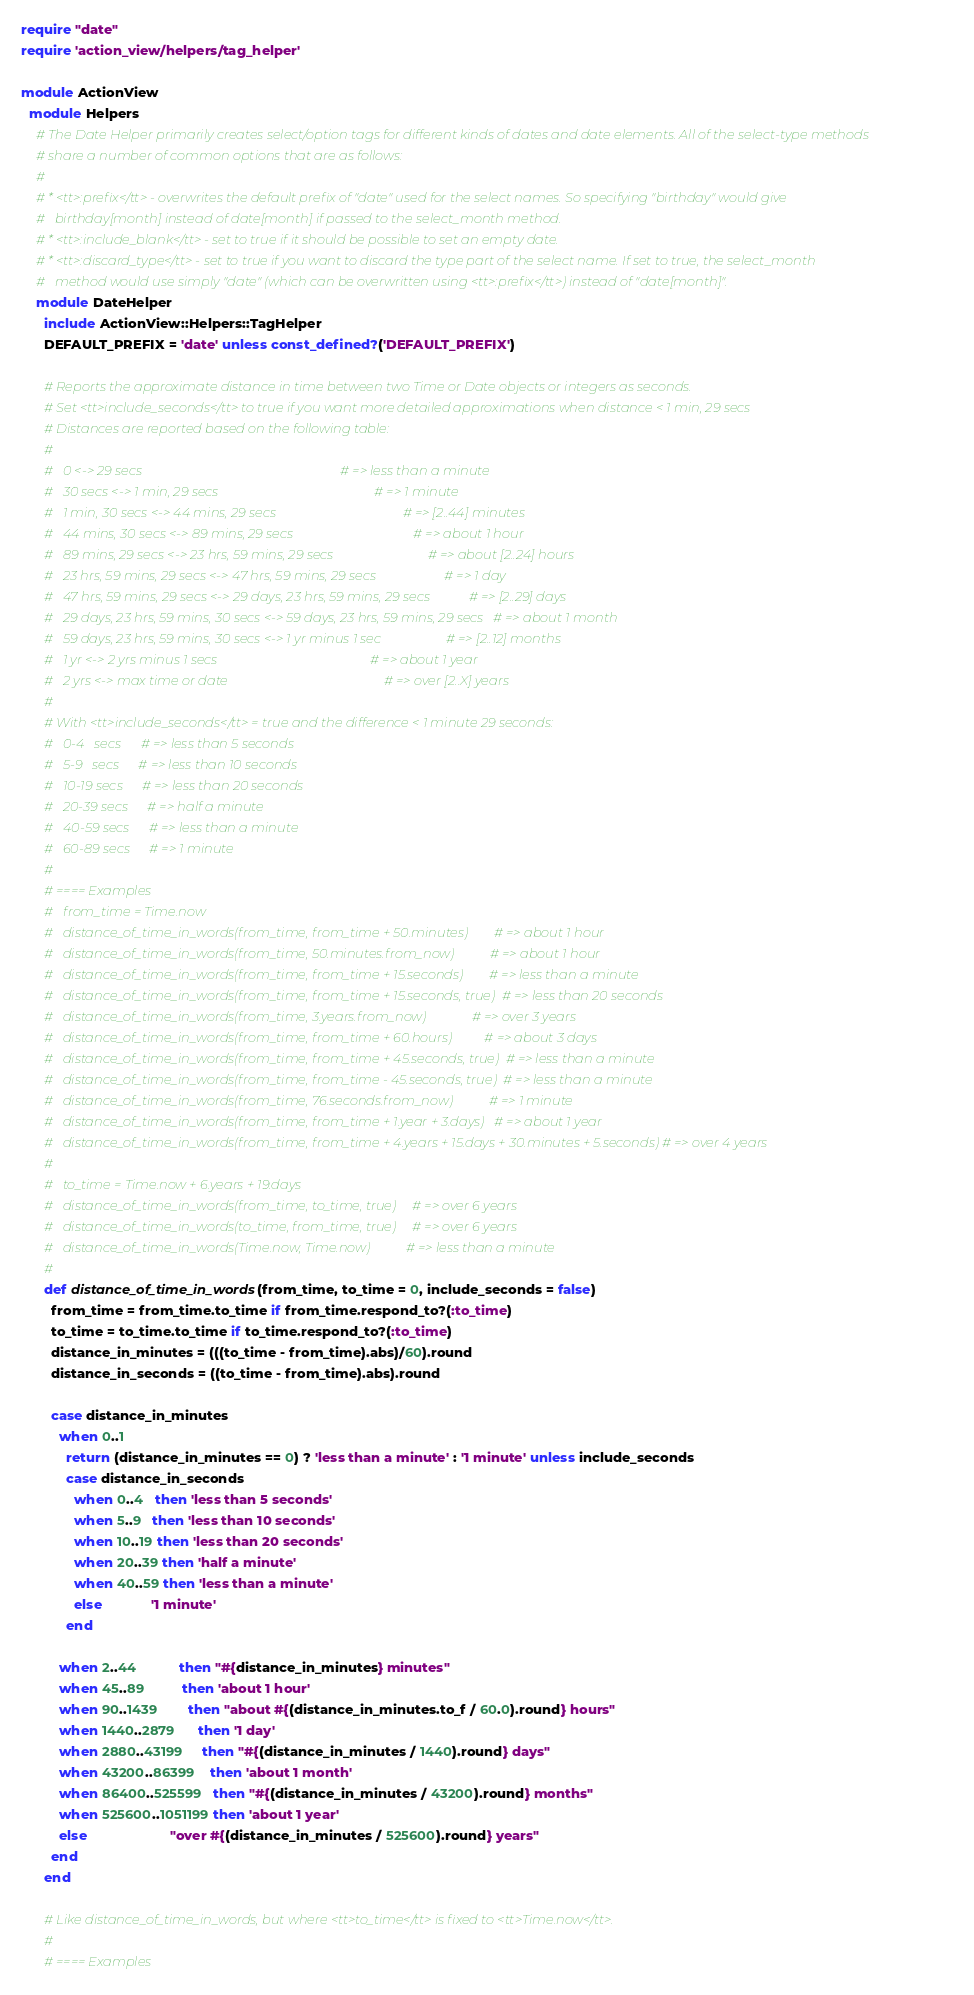Convert code to text. <code><loc_0><loc_0><loc_500><loc_500><_Ruby_>require "date"
require 'action_view/helpers/tag_helper'

module ActionView
  module Helpers
    # The Date Helper primarily creates select/option tags for different kinds of dates and date elements. All of the select-type methods
    # share a number of common options that are as follows:
    #
    # * <tt>:prefix</tt> - overwrites the default prefix of "date" used for the select names. So specifying "birthday" would give
    #   birthday[month] instead of date[month] if passed to the select_month method.
    # * <tt>:include_blank</tt> - set to true if it should be possible to set an empty date.
    # * <tt>:discard_type</tt> - set to true if you want to discard the type part of the select name. If set to true, the select_month
    #   method would use simply "date" (which can be overwritten using <tt>:prefix</tt>) instead of "date[month]".
    module DateHelper
      include ActionView::Helpers::TagHelper
      DEFAULT_PREFIX = 'date' unless const_defined?('DEFAULT_PREFIX')

      # Reports the approximate distance in time between two Time or Date objects or integers as seconds.
      # Set <tt>include_seconds</tt> to true if you want more detailed approximations when distance < 1 min, 29 secs
      # Distances are reported based on the following table:
      #
      #   0 <-> 29 secs                                                             # => less than a minute
      #   30 secs <-> 1 min, 29 secs                                                # => 1 minute
      #   1 min, 30 secs <-> 44 mins, 29 secs                                       # => [2..44] minutes
      #   44 mins, 30 secs <-> 89 mins, 29 secs                                     # => about 1 hour
      #   89 mins, 29 secs <-> 23 hrs, 59 mins, 29 secs                             # => about [2..24] hours
      #   23 hrs, 59 mins, 29 secs <-> 47 hrs, 59 mins, 29 secs                     # => 1 day
      #   47 hrs, 59 mins, 29 secs <-> 29 days, 23 hrs, 59 mins, 29 secs            # => [2..29] days
      #   29 days, 23 hrs, 59 mins, 30 secs <-> 59 days, 23 hrs, 59 mins, 29 secs   # => about 1 month
      #   59 days, 23 hrs, 59 mins, 30 secs <-> 1 yr minus 1 sec                    # => [2..12] months
      #   1 yr <-> 2 yrs minus 1 secs                                               # => about 1 year
      #   2 yrs <-> max time or date                                                # => over [2..X] years
      #
      # With <tt>include_seconds</tt> = true and the difference < 1 minute 29 seconds:
      #   0-4   secs      # => less than 5 seconds
      #   5-9   secs      # => less than 10 seconds
      #   10-19 secs      # => less than 20 seconds
      #   20-39 secs      # => half a minute
      #   40-59 secs      # => less than a minute
      #   60-89 secs      # => 1 minute
      #
      # ==== Examples
      #   from_time = Time.now
      #   distance_of_time_in_words(from_time, from_time + 50.minutes)        # => about 1 hour
      #   distance_of_time_in_words(from_time, 50.minutes.from_now)           # => about 1 hour
      #   distance_of_time_in_words(from_time, from_time + 15.seconds)        # => less than a minute
      #   distance_of_time_in_words(from_time, from_time + 15.seconds, true)  # => less than 20 seconds
      #   distance_of_time_in_words(from_time, 3.years.from_now)              # => over 3 years
      #   distance_of_time_in_words(from_time, from_time + 60.hours)          # => about 3 days
      #   distance_of_time_in_words(from_time, from_time + 45.seconds, true)  # => less than a minute
      #   distance_of_time_in_words(from_time, from_time - 45.seconds, true)  # => less than a minute
      #   distance_of_time_in_words(from_time, 76.seconds.from_now)           # => 1 minute
      #   distance_of_time_in_words(from_time, from_time + 1.year + 3.days)   # => about 1 year
      #   distance_of_time_in_words(from_time, from_time + 4.years + 15.days + 30.minutes + 5.seconds) # => over 4 years
      #
      #   to_time = Time.now + 6.years + 19.days
      #   distance_of_time_in_words(from_time, to_time, true)     # => over 6 years
      #   distance_of_time_in_words(to_time, from_time, true)     # => over 6 years
      #   distance_of_time_in_words(Time.now, Time.now)           # => less than a minute
      #
      def distance_of_time_in_words(from_time, to_time = 0, include_seconds = false)
        from_time = from_time.to_time if from_time.respond_to?(:to_time)
        to_time = to_time.to_time if to_time.respond_to?(:to_time)
        distance_in_minutes = (((to_time - from_time).abs)/60).round
        distance_in_seconds = ((to_time - from_time).abs).round

        case distance_in_minutes
          when 0..1
            return (distance_in_minutes == 0) ? 'less than a minute' : '1 minute' unless include_seconds
            case distance_in_seconds
              when 0..4   then 'less than 5 seconds'
              when 5..9   then 'less than 10 seconds'
              when 10..19 then 'less than 20 seconds'
              when 20..39 then 'half a minute'
              when 40..59 then 'less than a minute'
              else             '1 minute'
            end

          when 2..44           then "#{distance_in_minutes} minutes"
          when 45..89          then 'about 1 hour'
          when 90..1439        then "about #{(distance_in_minutes.to_f / 60.0).round} hours"
          when 1440..2879      then '1 day'
          when 2880..43199     then "#{(distance_in_minutes / 1440).round} days"
          when 43200..86399    then 'about 1 month'
          when 86400..525599   then "#{(distance_in_minutes / 43200).round} months"
          when 525600..1051199 then 'about 1 year'
          else                      "over #{(distance_in_minutes / 525600).round} years"
        end
      end

      # Like distance_of_time_in_words, but where <tt>to_time</tt> is fixed to <tt>Time.now</tt>.
      #
      # ==== Examples</code> 